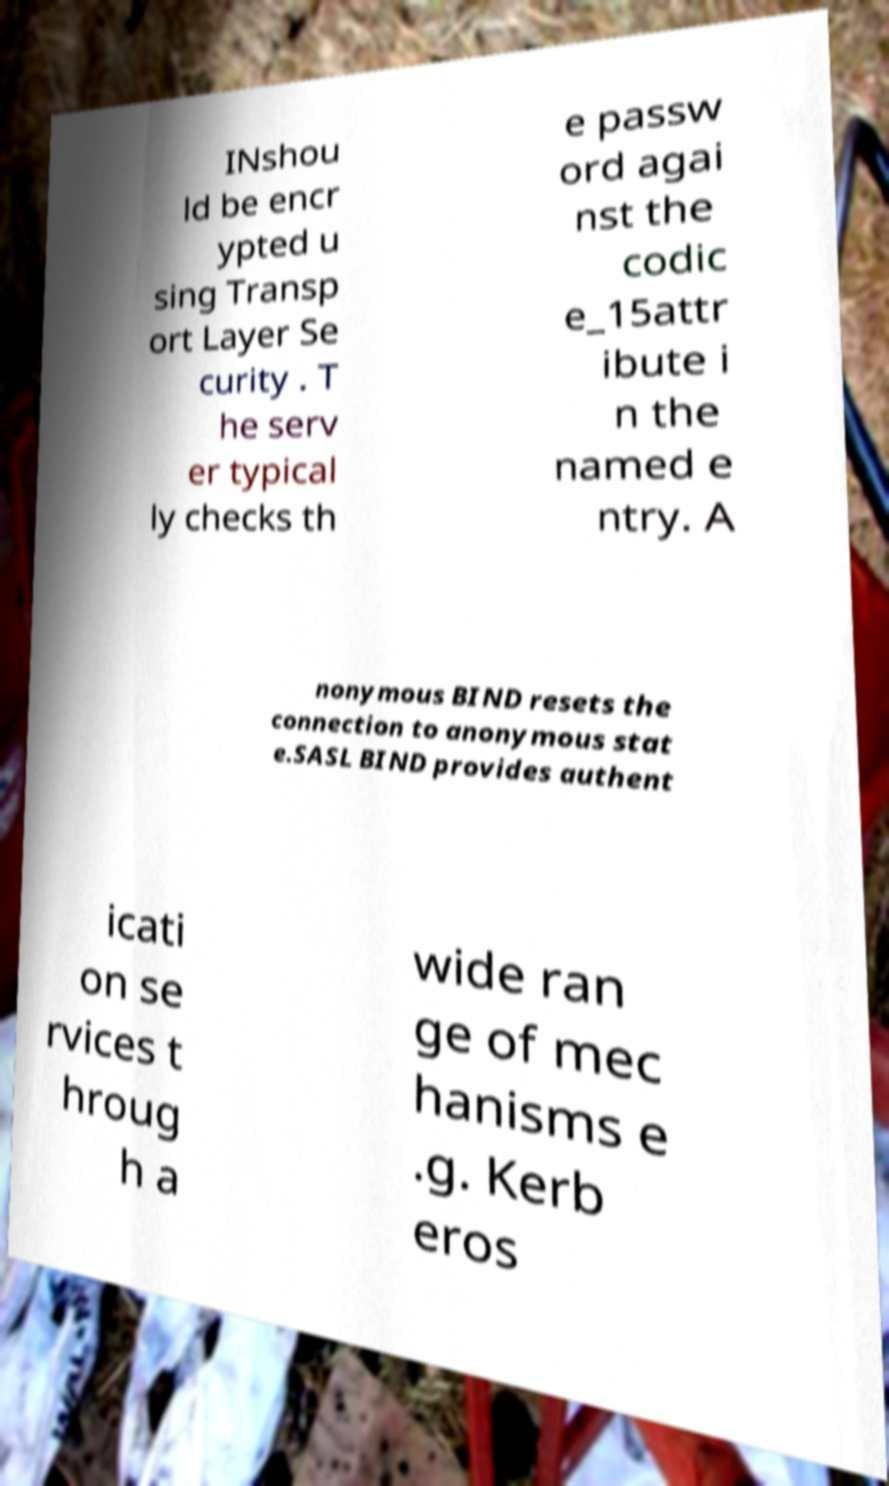Can you read and provide the text displayed in the image?This photo seems to have some interesting text. Can you extract and type it out for me? INshou ld be encr ypted u sing Transp ort Layer Se curity . T he serv er typical ly checks th e passw ord agai nst the codic e_15attr ibute i n the named e ntry. A nonymous BIND resets the connection to anonymous stat e.SASL BIND provides authent icati on se rvices t hroug h a wide ran ge of mec hanisms e .g. Kerb eros 